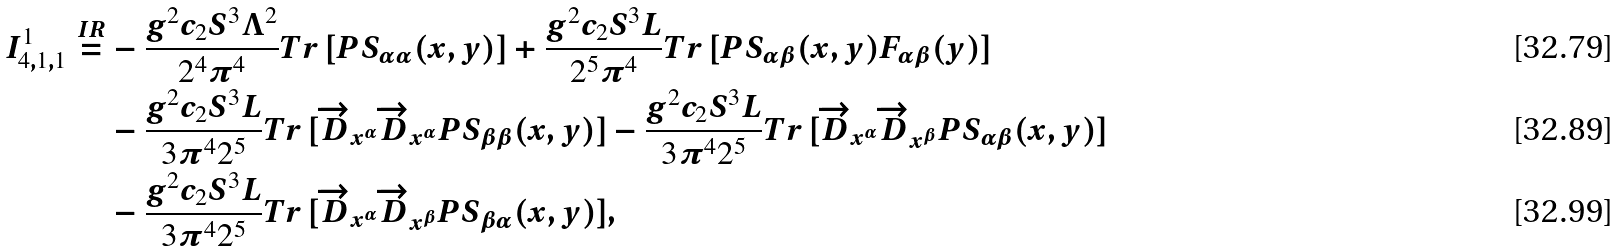<formula> <loc_0><loc_0><loc_500><loc_500>I ^ { 1 } _ { 4 , 1 , 1 } \stackrel { I R } { = } & - \frac { g ^ { 2 } c _ { 2 } S ^ { 3 } \Lambda ^ { 2 } } { 2 ^ { 4 } \pi ^ { 4 } } T r \, [ P S _ { \alpha \alpha } ( x , y ) ] + \frac { g ^ { 2 } c _ { 2 } S ^ { 3 } L } { 2 ^ { 5 } \pi ^ { 4 } } T r \, [ P S _ { \alpha \beta } ( x , y ) F _ { \alpha \beta } ( y ) ] \\ & - \frac { g ^ { 2 } c _ { 2 } S ^ { 3 } L } { 3 \pi ^ { 4 } 2 ^ { 5 } } T r \, [ \overrightarrow { D } _ { x ^ { \alpha } } \overrightarrow { D } _ { x ^ { \alpha } } P S _ { \beta \beta } ( x , y ) ] - \frac { g ^ { 2 } c _ { 2 } S ^ { 3 } L } { 3 \pi ^ { 4 } 2 ^ { 5 } } T r \, [ \overrightarrow { D } _ { x ^ { \alpha } } \overrightarrow { D } _ { x ^ { \beta } } P S _ { \alpha \beta } ( x , y ) ] \\ & - \frac { g ^ { 2 } c _ { 2 } S ^ { 3 } L } { 3 \pi ^ { 4 } 2 ^ { 5 } } T r \, [ \overrightarrow { D } _ { x ^ { \alpha } } \overrightarrow { D } _ { x ^ { \beta } } P S _ { \beta \alpha } ( x , y ) ] ,</formula> 